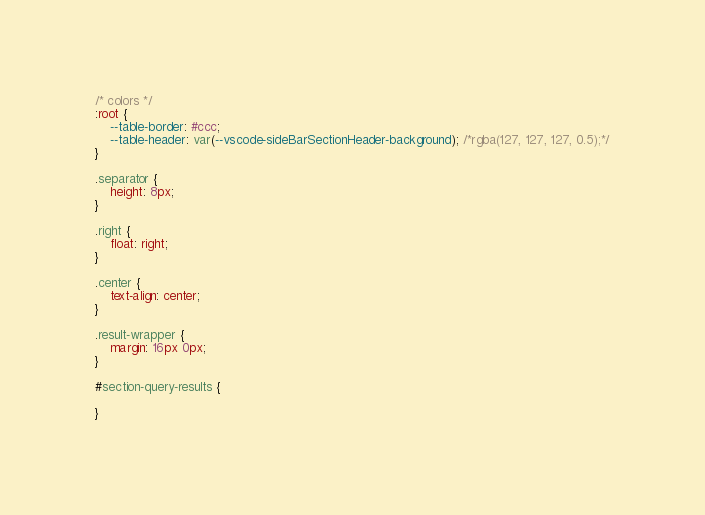<code> <loc_0><loc_0><loc_500><loc_500><_CSS_>/* colors */
:root {
    --table-border: #ccc;
    --table-header: var(--vscode-sideBarSectionHeader-background); /*rgba(127, 127, 127, 0.5);*/
}

.separator {
    height: 8px;
}

.right {
    float: right;
}

.center {
    text-align: center;
}

.result-wrapper {
    margin: 16px 0px;
}

#section-query-results {
    
}</code> 